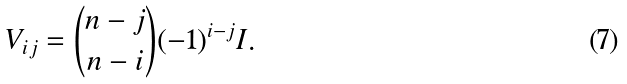Convert formula to latex. <formula><loc_0><loc_0><loc_500><loc_500>V _ { i j } = { n - j \choose n - i } ( - 1 ) ^ { i - j } I .</formula> 